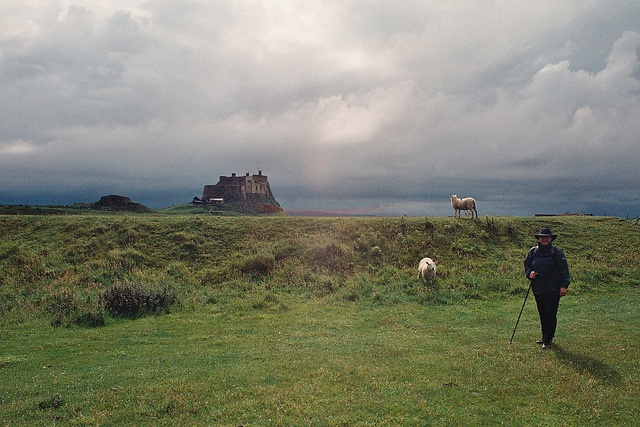Describe the objects in this image and their specific colors. I can see people in lightgray, black, maroon, gray, and darkgreen tones, sheep in lightgray, gray, black, and darkgray tones, sheep in lightgray, gray, black, beige, and tan tones, and backpack in lightgray, black, and gray tones in this image. 